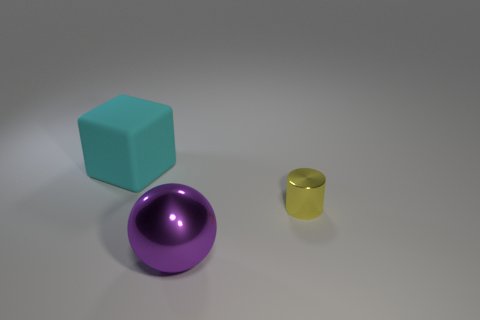Add 3 red spheres. How many objects exist? 6 Subtract all balls. How many objects are left? 2 Add 2 big green rubber objects. How many big green rubber objects exist? 2 Subtract 0 gray cubes. How many objects are left? 3 Subtract all tiny green matte balls. Subtract all large purple shiny balls. How many objects are left? 2 Add 1 small yellow things. How many small yellow things are left? 2 